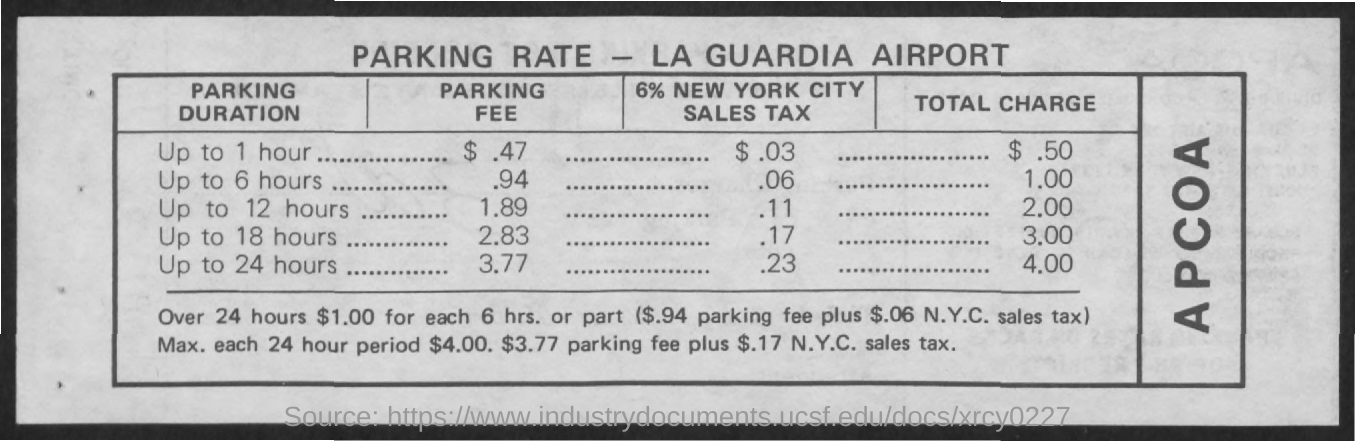Draw attention to some important aspects in this diagram. The total charge for up to 18 hours is 3.00. The parking fee for up to 1 hour is 0.47 dollars. The total charge for up to 6 hours is 1.00. The parking fee for up to 12 hours is $1.89. The parking fee for up to 24 hours is 3.77. 